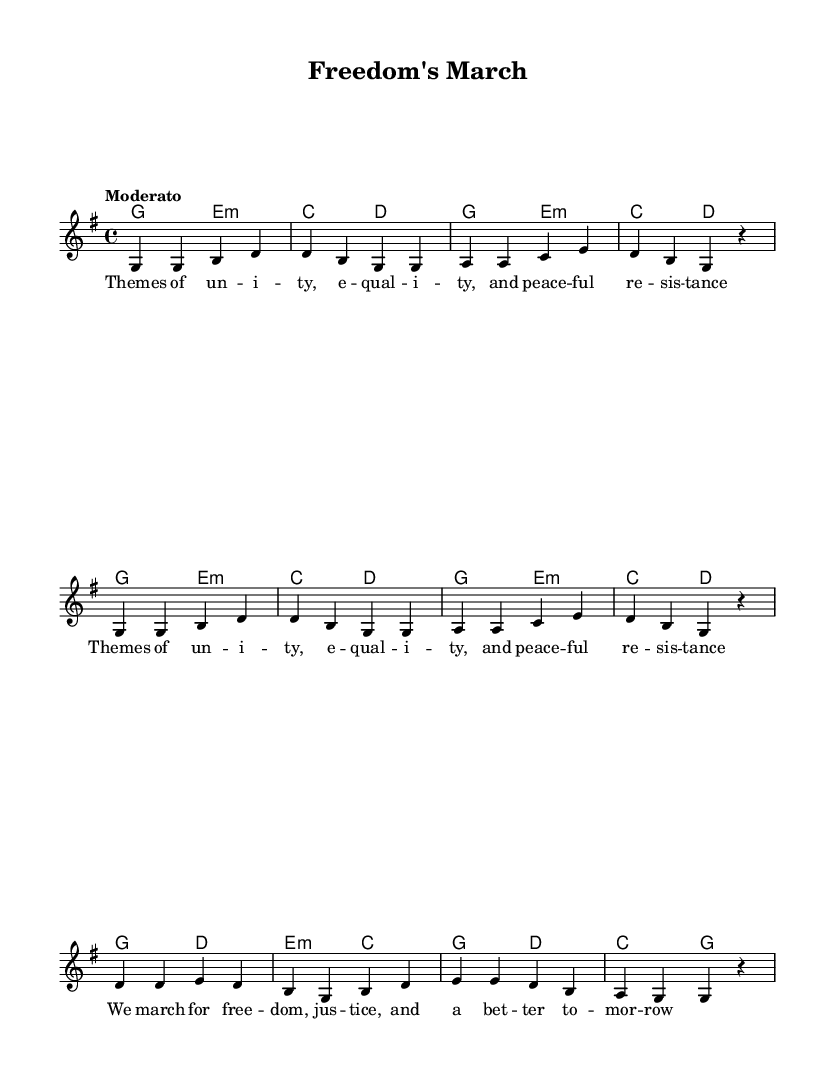What is the key signature of this music? The key signature indicates one sharp, which means the piece is in G major. In G major, the note 'F' is raised by a sharp, denoting the key signature.
Answer: G major What is the time signature of this music? The time signature shows a "4/4" at the beginning of the score, meaning there are four beats in each measure and the quarter note receives one beat.
Answer: 4/4 What is the tempo marking given for this piece? The tempo marking at the beginning of the score states "Moderato," which indicates a moderate pace for the piece.
Answer: Moderato How many measures are there in the melody section? The melody section consists of eight measures, as indicated by the measures indicated in the score. There is a clear separation between each set of notes that represent measures.
Answer: Eight measures What is the primary theme expressed in the lyrics of this song? The lyrics suggest themes of unity, equality, and peaceful resistance, reflecting the messages of the civil rights movement. This is understood by reading the lyric content provided under the melody.
Answer: Unity Which chords are used in the first two measures? The chords in the first two measures are G major and E minor, as indicated by the chord symbols placed above the staff in the first two measures of the score.
Answer: G and E minor What vocal line is represented in this music section? The vocal line in this section consists of the main melody, which is written in the relative octave and follows the notes associated with the lyrics about freedom and justice.
Answer: Main melody 